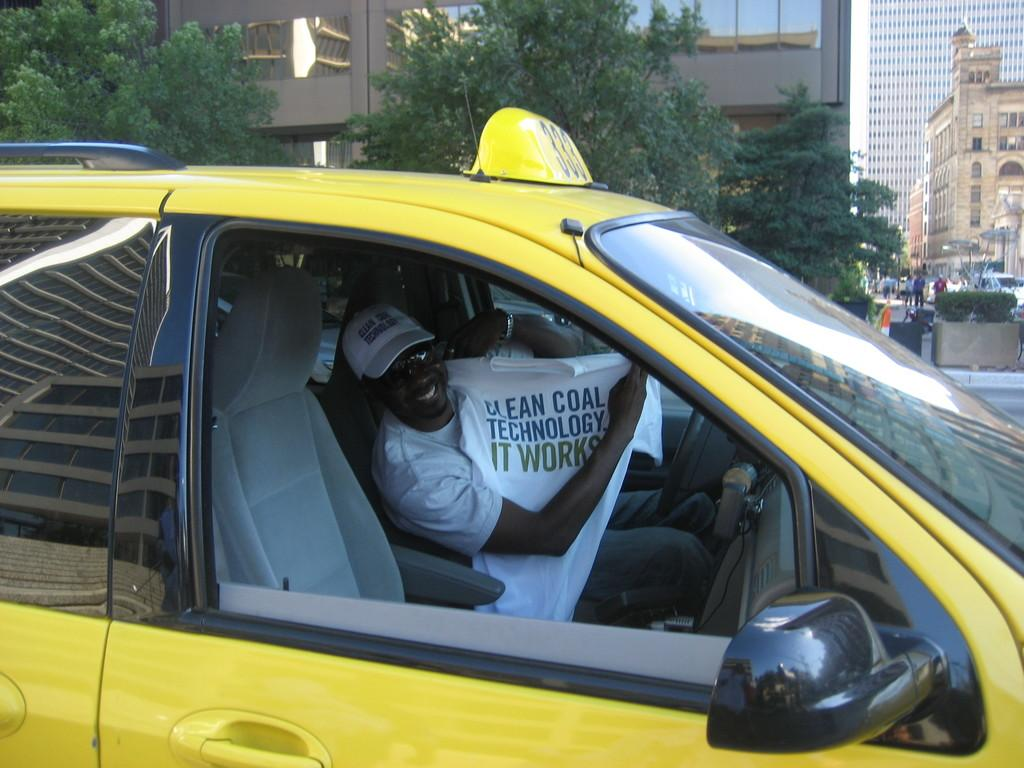<image>
Write a terse but informative summary of the picture. A taxi driver holds up a shirt touting clean coal technology. 